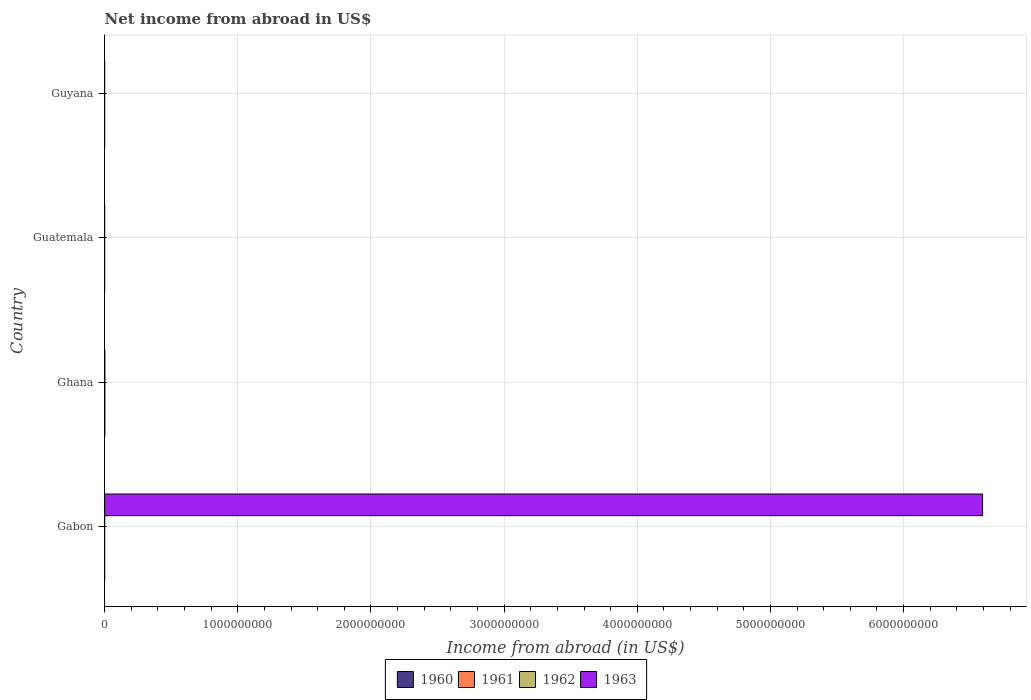How many different coloured bars are there?
Keep it short and to the point. 1. How many bars are there on the 3rd tick from the bottom?
Make the answer very short. 0. What is the label of the 4th group of bars from the top?
Give a very brief answer. Gabon. In how many cases, is the number of bars for a given country not equal to the number of legend labels?
Offer a very short reply. 4. What is the net income from abroad in 1963 in Guatemala?
Provide a short and direct response. 0. Across all countries, what is the maximum net income from abroad in 1963?
Provide a short and direct response. 6.59e+09. What is the difference between the net income from abroad in 1960 in Ghana and the net income from abroad in 1963 in Gabon?
Your answer should be compact. -6.59e+09. What is the average net income from abroad in 1960 per country?
Ensure brevity in your answer.  0. In how many countries, is the net income from abroad in 1960 greater than 4800000000 US$?
Ensure brevity in your answer.  0. What is the difference between the highest and the lowest net income from abroad in 1963?
Your response must be concise. 6.59e+09. Is it the case that in every country, the sum of the net income from abroad in 1963 and net income from abroad in 1962 is greater than the net income from abroad in 1960?
Make the answer very short. No. How many bars are there?
Keep it short and to the point. 1. Are all the bars in the graph horizontal?
Offer a very short reply. Yes. What is the difference between two consecutive major ticks on the X-axis?
Give a very brief answer. 1.00e+09. Are the values on the major ticks of X-axis written in scientific E-notation?
Offer a very short reply. No. Does the graph contain any zero values?
Offer a terse response. Yes. Does the graph contain grids?
Give a very brief answer. Yes. What is the title of the graph?
Offer a very short reply. Net income from abroad in US$. Does "1989" appear as one of the legend labels in the graph?
Keep it short and to the point. No. What is the label or title of the X-axis?
Offer a terse response. Income from abroad (in US$). What is the label or title of the Y-axis?
Provide a succinct answer. Country. What is the Income from abroad (in US$) in 1961 in Gabon?
Provide a short and direct response. 0. What is the Income from abroad (in US$) in 1962 in Gabon?
Provide a succinct answer. 0. What is the Income from abroad (in US$) of 1963 in Gabon?
Ensure brevity in your answer.  6.59e+09. What is the Income from abroad (in US$) of 1961 in Ghana?
Ensure brevity in your answer.  0. What is the Income from abroad (in US$) in 1962 in Ghana?
Your answer should be very brief. 0. What is the Income from abroad (in US$) in 1960 in Guatemala?
Make the answer very short. 0. What is the Income from abroad (in US$) of 1962 in Guatemala?
Provide a succinct answer. 0. What is the Income from abroad (in US$) in 1963 in Guatemala?
Your answer should be compact. 0. What is the Income from abroad (in US$) of 1960 in Guyana?
Keep it short and to the point. 0. What is the Income from abroad (in US$) of 1961 in Guyana?
Give a very brief answer. 0. What is the Income from abroad (in US$) in 1962 in Guyana?
Make the answer very short. 0. Across all countries, what is the maximum Income from abroad (in US$) of 1963?
Provide a short and direct response. 6.59e+09. What is the total Income from abroad (in US$) of 1961 in the graph?
Your answer should be compact. 0. What is the total Income from abroad (in US$) in 1962 in the graph?
Offer a very short reply. 0. What is the total Income from abroad (in US$) of 1963 in the graph?
Your answer should be very brief. 6.59e+09. What is the average Income from abroad (in US$) of 1960 per country?
Your response must be concise. 0. What is the average Income from abroad (in US$) of 1961 per country?
Keep it short and to the point. 0. What is the average Income from abroad (in US$) of 1962 per country?
Provide a succinct answer. 0. What is the average Income from abroad (in US$) in 1963 per country?
Provide a succinct answer. 1.65e+09. What is the difference between the highest and the lowest Income from abroad (in US$) of 1963?
Your answer should be compact. 6.59e+09. 